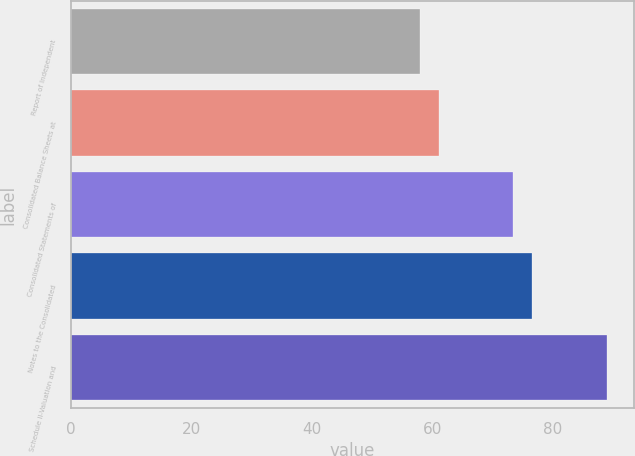Convert chart. <chart><loc_0><loc_0><loc_500><loc_500><bar_chart><fcel>Report of Independent<fcel>Consolidated Balance Sheets at<fcel>Consolidated Statements of<fcel>Notes to the Consolidated<fcel>Schedule II-Valuation and<nl><fcel>58<fcel>61.1<fcel>73.5<fcel>76.6<fcel>89<nl></chart> 